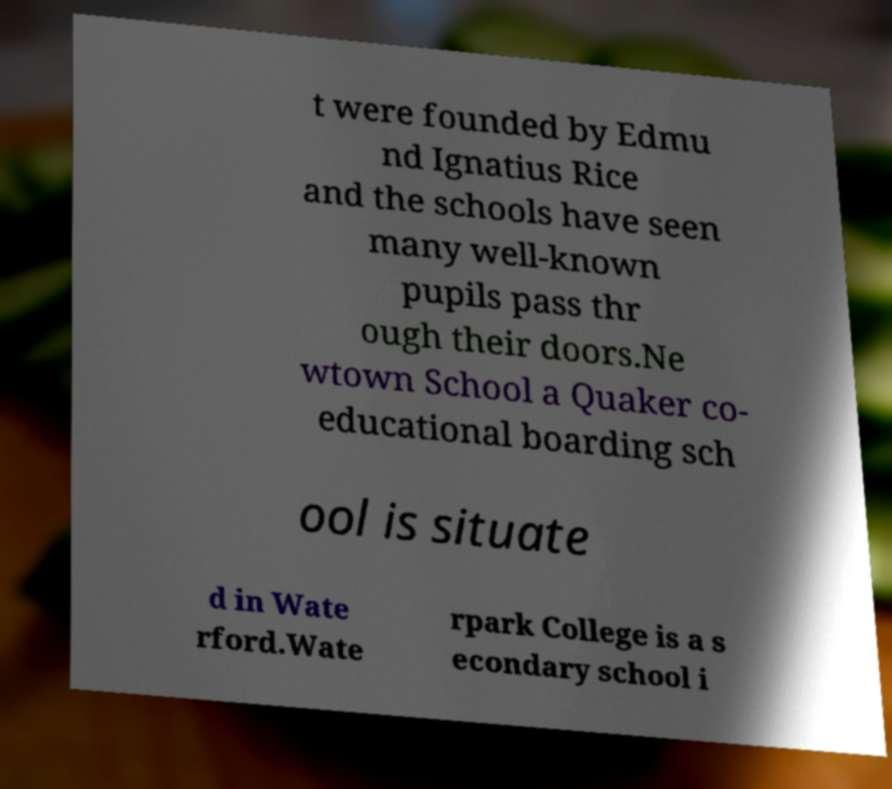Please identify and transcribe the text found in this image. t were founded by Edmu nd Ignatius Rice and the schools have seen many well-known pupils pass thr ough their doors.Ne wtown School a Quaker co- educational boarding sch ool is situate d in Wate rford.Wate rpark College is a s econdary school i 